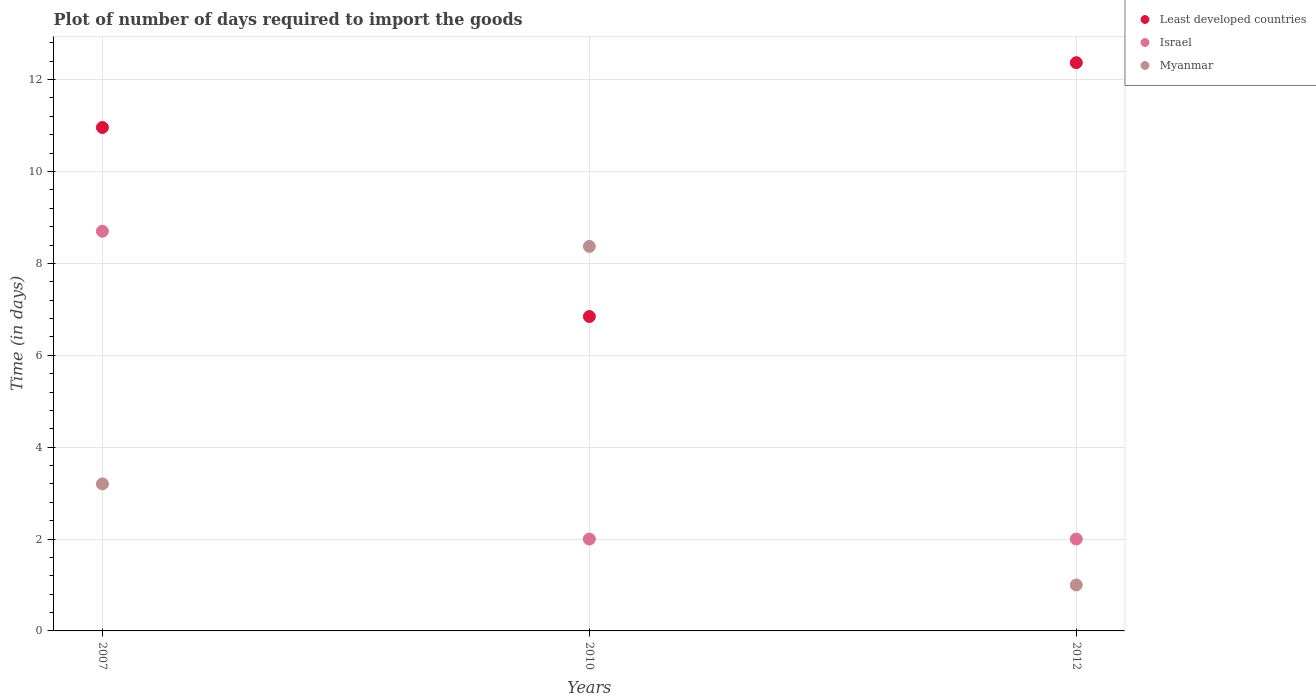Is the number of dotlines equal to the number of legend labels?
Ensure brevity in your answer.  Yes. What is the time required to import goods in Myanmar in 2012?
Give a very brief answer. 1. Across all years, what is the minimum time required to import goods in Israel?
Offer a terse response. 2. In which year was the time required to import goods in Least developed countries maximum?
Provide a short and direct response. 2012. In which year was the time required to import goods in Myanmar minimum?
Your answer should be very brief. 2012. What is the total time required to import goods in Least developed countries in the graph?
Your response must be concise. 30.17. What is the difference between the time required to import goods in Least developed countries in 2007 and that in 2012?
Offer a very short reply. -1.41. What is the difference between the time required to import goods in Israel in 2007 and the time required to import goods in Least developed countries in 2012?
Give a very brief answer. -3.67. What is the average time required to import goods in Israel per year?
Provide a succinct answer. 4.23. In the year 2007, what is the difference between the time required to import goods in Least developed countries and time required to import goods in Israel?
Provide a succinct answer. 2.26. Is the difference between the time required to import goods in Least developed countries in 2007 and 2010 greater than the difference between the time required to import goods in Israel in 2007 and 2010?
Your answer should be very brief. No. What is the difference between the highest and the second highest time required to import goods in Israel?
Offer a very short reply. 6.7. What is the difference between the highest and the lowest time required to import goods in Least developed countries?
Provide a short and direct response. 5.52. In how many years, is the time required to import goods in Israel greater than the average time required to import goods in Israel taken over all years?
Your answer should be compact. 1. Is the sum of the time required to import goods in Least developed countries in 2007 and 2010 greater than the maximum time required to import goods in Myanmar across all years?
Your answer should be very brief. Yes. Does the time required to import goods in Myanmar monotonically increase over the years?
Your answer should be compact. No. What is the difference between two consecutive major ticks on the Y-axis?
Provide a short and direct response. 2. Are the values on the major ticks of Y-axis written in scientific E-notation?
Your answer should be compact. No. Does the graph contain any zero values?
Ensure brevity in your answer.  No. Where does the legend appear in the graph?
Give a very brief answer. Top right. How are the legend labels stacked?
Your answer should be very brief. Vertical. What is the title of the graph?
Your answer should be very brief. Plot of number of days required to import the goods. Does "Cote d'Ivoire" appear as one of the legend labels in the graph?
Ensure brevity in your answer.  No. What is the label or title of the Y-axis?
Offer a terse response. Time (in days). What is the Time (in days) in Least developed countries in 2007?
Your answer should be compact. 10.96. What is the Time (in days) in Myanmar in 2007?
Offer a very short reply. 3.2. What is the Time (in days) in Least developed countries in 2010?
Give a very brief answer. 6.84. What is the Time (in days) in Israel in 2010?
Your answer should be compact. 2. What is the Time (in days) in Myanmar in 2010?
Provide a succinct answer. 8.37. What is the Time (in days) in Least developed countries in 2012?
Your answer should be compact. 12.37. What is the Time (in days) in Israel in 2012?
Offer a very short reply. 2. Across all years, what is the maximum Time (in days) in Least developed countries?
Make the answer very short. 12.37. Across all years, what is the maximum Time (in days) of Israel?
Offer a very short reply. 8.7. Across all years, what is the maximum Time (in days) of Myanmar?
Your answer should be compact. 8.37. Across all years, what is the minimum Time (in days) of Least developed countries?
Your answer should be very brief. 6.84. Across all years, what is the minimum Time (in days) in Myanmar?
Offer a very short reply. 1. What is the total Time (in days) in Least developed countries in the graph?
Give a very brief answer. 30.17. What is the total Time (in days) of Myanmar in the graph?
Ensure brevity in your answer.  12.57. What is the difference between the Time (in days) in Least developed countries in 2007 and that in 2010?
Your answer should be very brief. 4.11. What is the difference between the Time (in days) in Israel in 2007 and that in 2010?
Provide a succinct answer. 6.7. What is the difference between the Time (in days) of Myanmar in 2007 and that in 2010?
Offer a terse response. -5.17. What is the difference between the Time (in days) of Least developed countries in 2007 and that in 2012?
Make the answer very short. -1.41. What is the difference between the Time (in days) in Least developed countries in 2010 and that in 2012?
Your answer should be compact. -5.52. What is the difference between the Time (in days) in Israel in 2010 and that in 2012?
Provide a short and direct response. 0. What is the difference between the Time (in days) of Myanmar in 2010 and that in 2012?
Your answer should be very brief. 7.37. What is the difference between the Time (in days) in Least developed countries in 2007 and the Time (in days) in Israel in 2010?
Offer a very short reply. 8.96. What is the difference between the Time (in days) of Least developed countries in 2007 and the Time (in days) of Myanmar in 2010?
Ensure brevity in your answer.  2.59. What is the difference between the Time (in days) of Israel in 2007 and the Time (in days) of Myanmar in 2010?
Your answer should be compact. 0.33. What is the difference between the Time (in days) in Least developed countries in 2007 and the Time (in days) in Israel in 2012?
Offer a terse response. 8.96. What is the difference between the Time (in days) in Least developed countries in 2007 and the Time (in days) in Myanmar in 2012?
Keep it short and to the point. 9.96. What is the difference between the Time (in days) in Israel in 2007 and the Time (in days) in Myanmar in 2012?
Provide a short and direct response. 7.7. What is the difference between the Time (in days) of Least developed countries in 2010 and the Time (in days) of Israel in 2012?
Provide a succinct answer. 4.84. What is the difference between the Time (in days) in Least developed countries in 2010 and the Time (in days) in Myanmar in 2012?
Your answer should be compact. 5.84. What is the average Time (in days) in Least developed countries per year?
Keep it short and to the point. 10.06. What is the average Time (in days) of Israel per year?
Provide a succinct answer. 4.23. What is the average Time (in days) in Myanmar per year?
Your answer should be very brief. 4.19. In the year 2007, what is the difference between the Time (in days) in Least developed countries and Time (in days) in Israel?
Offer a terse response. 2.26. In the year 2007, what is the difference between the Time (in days) in Least developed countries and Time (in days) in Myanmar?
Keep it short and to the point. 7.76. In the year 2007, what is the difference between the Time (in days) in Israel and Time (in days) in Myanmar?
Your answer should be compact. 5.5. In the year 2010, what is the difference between the Time (in days) in Least developed countries and Time (in days) in Israel?
Make the answer very short. 4.84. In the year 2010, what is the difference between the Time (in days) in Least developed countries and Time (in days) in Myanmar?
Provide a succinct answer. -1.53. In the year 2010, what is the difference between the Time (in days) of Israel and Time (in days) of Myanmar?
Keep it short and to the point. -6.37. In the year 2012, what is the difference between the Time (in days) in Least developed countries and Time (in days) in Israel?
Provide a succinct answer. 10.37. In the year 2012, what is the difference between the Time (in days) of Least developed countries and Time (in days) of Myanmar?
Provide a short and direct response. 11.37. In the year 2012, what is the difference between the Time (in days) of Israel and Time (in days) of Myanmar?
Provide a short and direct response. 1. What is the ratio of the Time (in days) in Least developed countries in 2007 to that in 2010?
Your response must be concise. 1.6. What is the ratio of the Time (in days) of Israel in 2007 to that in 2010?
Provide a succinct answer. 4.35. What is the ratio of the Time (in days) in Myanmar in 2007 to that in 2010?
Offer a very short reply. 0.38. What is the ratio of the Time (in days) of Least developed countries in 2007 to that in 2012?
Ensure brevity in your answer.  0.89. What is the ratio of the Time (in days) in Israel in 2007 to that in 2012?
Offer a very short reply. 4.35. What is the ratio of the Time (in days) in Myanmar in 2007 to that in 2012?
Provide a short and direct response. 3.2. What is the ratio of the Time (in days) in Least developed countries in 2010 to that in 2012?
Your response must be concise. 0.55. What is the ratio of the Time (in days) in Israel in 2010 to that in 2012?
Your answer should be compact. 1. What is the ratio of the Time (in days) in Myanmar in 2010 to that in 2012?
Provide a succinct answer. 8.37. What is the difference between the highest and the second highest Time (in days) of Least developed countries?
Your answer should be very brief. 1.41. What is the difference between the highest and the second highest Time (in days) in Israel?
Provide a succinct answer. 6.7. What is the difference between the highest and the second highest Time (in days) in Myanmar?
Provide a succinct answer. 5.17. What is the difference between the highest and the lowest Time (in days) of Least developed countries?
Give a very brief answer. 5.52. What is the difference between the highest and the lowest Time (in days) in Israel?
Provide a succinct answer. 6.7. What is the difference between the highest and the lowest Time (in days) of Myanmar?
Give a very brief answer. 7.37. 